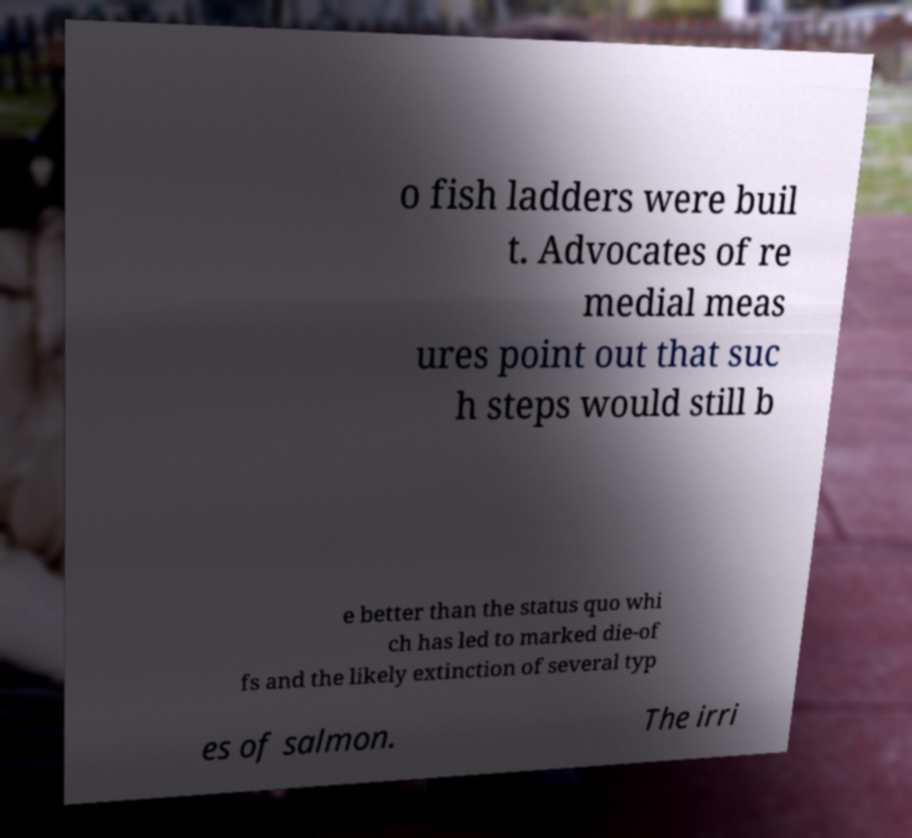Can you read and provide the text displayed in the image?This photo seems to have some interesting text. Can you extract and type it out for me? o fish ladders were buil t. Advocates of re medial meas ures point out that suc h steps would still b e better than the status quo whi ch has led to marked die-of fs and the likely extinction of several typ es of salmon. The irri 